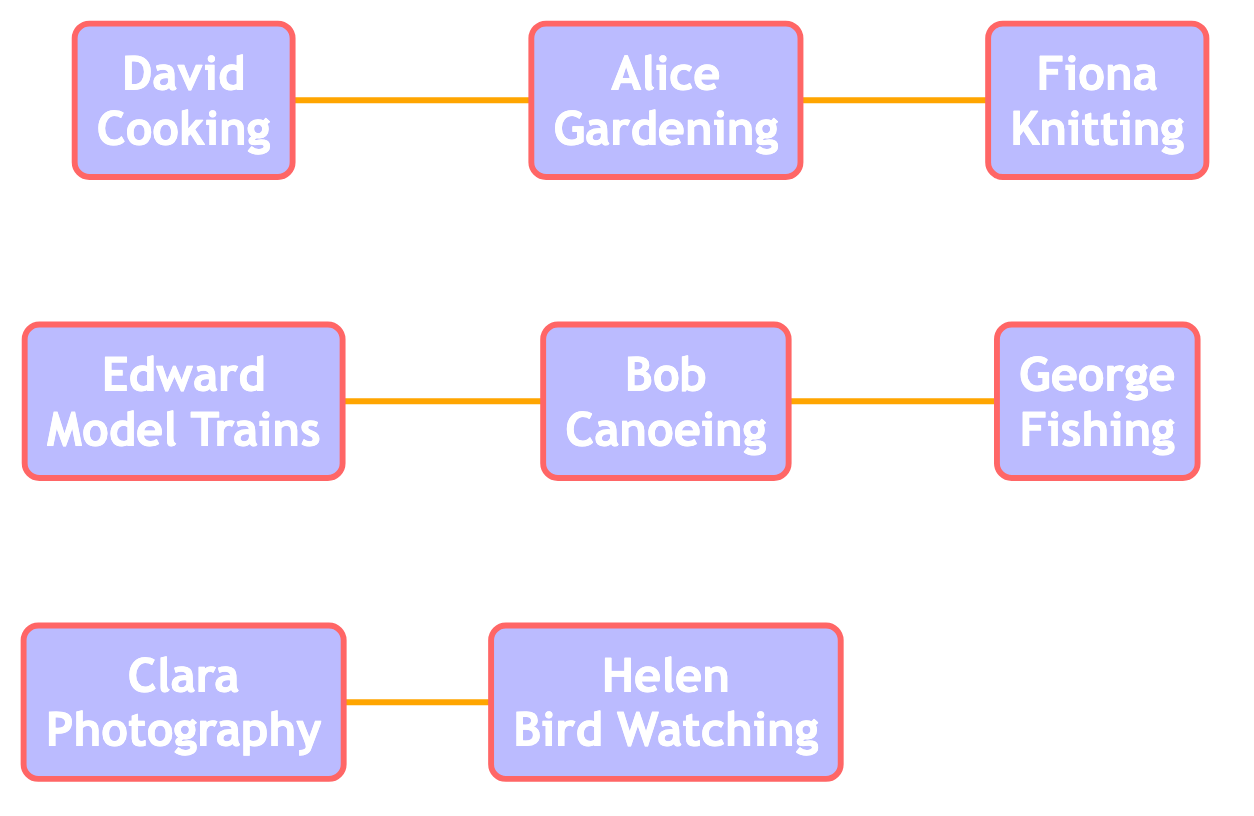What is Alice's hobby? The diagram shows that Alice is represented by a node labeled "Alice" with the hobby described as "Gardening" underneath her name.
Answer: Gardening Who is connected to Bob? Bob has edges connecting him to George and Edward. Since the question asks for the relationship in general, we can refer to George as one of the individuals connected to Bob.
Answer: George How many edges are in the graph? By examining the edges listed in the diagram, we count a total of five connections: Alice to Fiona, Bob to George, Clara to Helen, David to Alice, and Edward to Bob.
Answer: 5 What hobby does Clara have? Clara's node displays the name "Clara" along with her hobby labeled as "Photography" directly below. Thus, we can identify Clara's hobby through this visualization.
Answer: Photography Which family member has a hobby of Fishing? The graph indicates that George is connected to Bob, and looking at George's label, we see he has the hobby of "Fishing" below his name.
Answer: George Who has a direct connection with Alice? The diagram shows an edge connecting Alice to Fiona and also to David, indicating that both Fiona and David are directly connected to Alice.
Answer: Fiona Which two family members enjoy gardening and cooking? The graph identifies Alice with "Gardening" and David with "Cooking." Both hobbies are provided in their respective nodes, showing their interests.
Answer: Gardening and Cooking Is there anyone who shares a connection with both Bob and Alice? Considering the graph, Bob connects to George and Edward while Alice connects to Fiona and David. No person is directly connected to both Bob and Alice based on the edges shown.
Answer: No What is the relationship between Clara and Helen? The diagram depicts an edge connecting Clara to Helen, indicating a direct relationship or connection between the two family members.
Answer: Connected 